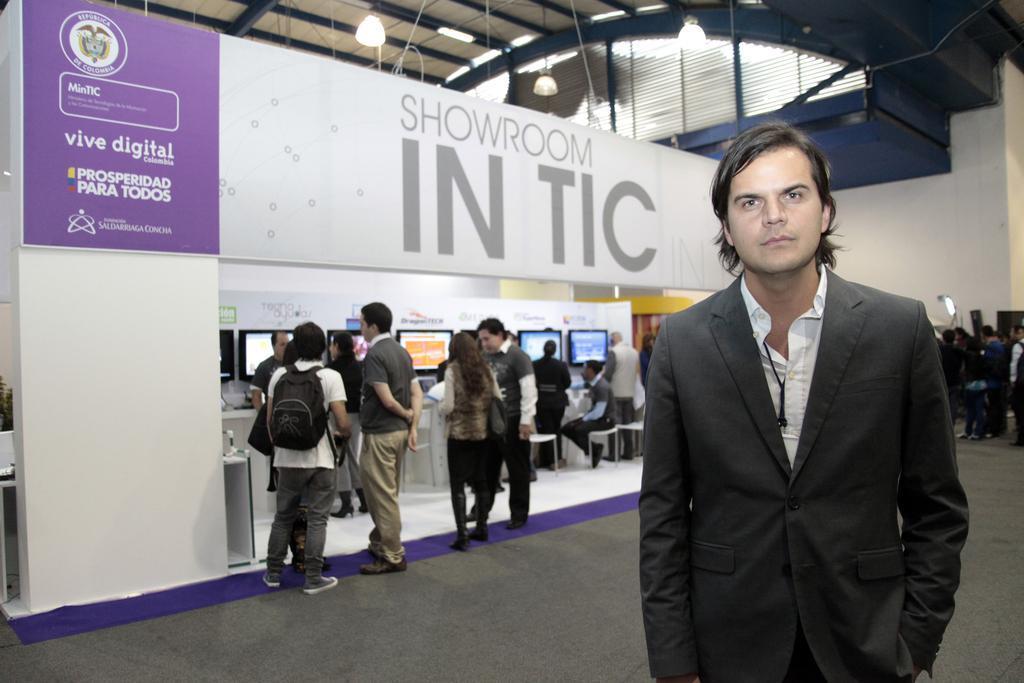Can you describe this image briefly? In the foreground of the picture there is a person standing. On the left there is a store, in the store there are monitors, chairs, people and other objects. On the right there are people. At the top there are lights to the ceiling. 